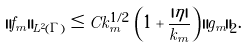<formula> <loc_0><loc_0><loc_500><loc_500>\| f _ { m } \| _ { L ^ { 2 } ( \Gamma ) } \leq C k _ { m } ^ { 1 / 2 } \, \left ( 1 + \frac { | \eta | } { k _ { m } } \right ) \, \| g _ { m } \| _ { 2 } .</formula> 